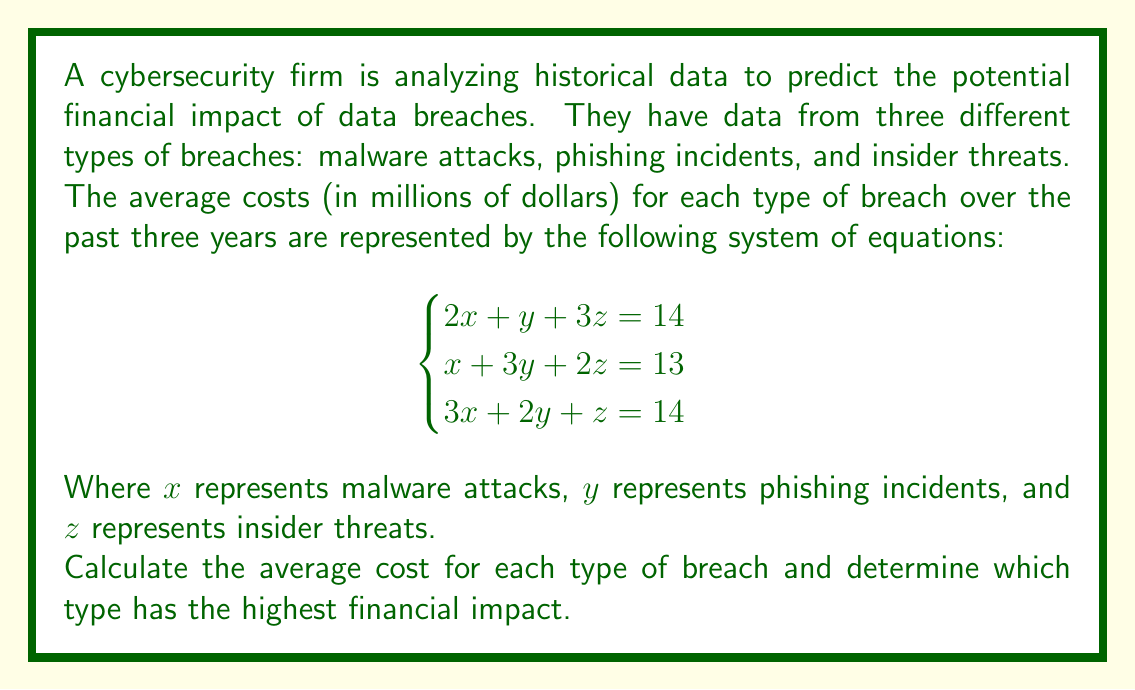Help me with this question. To solve this system of equations, we'll use the elimination method:

1) Multiply the first equation by 3 and the third equation by -2:
   $$6x + 3y + 9z = 42$$
   $$-6x - 4y - 2z = -28$$

2) Add these equations to eliminate x:
   $$-y + 7z = 14$$ (Equation 4)

3) Multiply the second equation by 2 and subtract it from Equation 4:
   $$2x + 6y + 4z = 26$$
   $$-y + 7z = 14$$
   $$2x + 7y - 3z = 12$$ (Equation 5)

4) Multiply the first equation by -1 and add it to Equation 5:
   $$-2x - y - 3z = -14$$
   $$2x + 7y - 3z = 12$$
   $$6y - 6z = -2$$
   $$y - z = -\frac{1}{3}$$ (Equation 6)

5) Substitute Equation 6 into Equation 4:
   $$-y + 7z = 14$$
   $$-(z - \frac{1}{3}) + 7z = 14$$
   $$6z + \frac{1}{3} = 14$$
   $$6z = \frac{41}{3}$$
   $$z = \frac{41}{18} \approx 2.28$$

6) Substitute z back into Equation 6 to find y:
   $$y - 2.28 = -\frac{1}{3}$$
   $$y = 1.95$$

7) Substitute y and z into the first equation to find x:
   $$2x + 1.95 + 3(2.28) = 14$$
   $$2x + 1.95 + 6.84 = 14$$
   $$2x = 5.21$$
   $$x = 2.61$$

Therefore, the average costs are:
$x$ (malware attacks) = $2.61 million
$y$ (phishing incidents) = $1.95 million
$z$ (insider threats) = $2.28 million

The type with the highest financial impact is malware attacks at $2.61 million.
Answer: Malware attacks: $2.61 million
Phishing incidents: $1.95 million
Insider threats: $2.28 million

The type with the highest financial impact is malware attacks. 